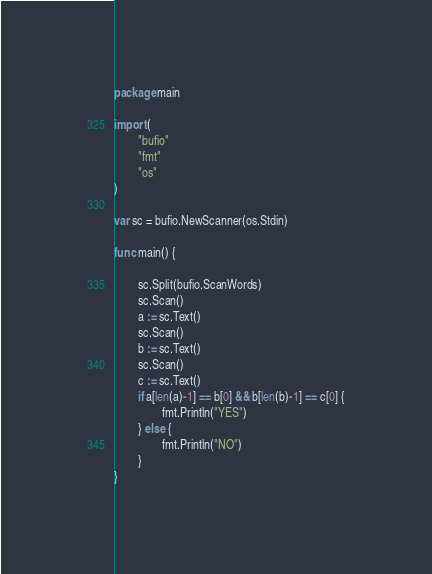Convert code to text. <code><loc_0><loc_0><loc_500><loc_500><_Go_>package main

import (
        "bufio"
        "fmt"
        "os"
)

var sc = bufio.NewScanner(os.Stdin)

func main() {

        sc.Split(bufio.ScanWords)
        sc.Scan()
        a := sc.Text()
        sc.Scan()
        b := sc.Text()
        sc.Scan()
        c := sc.Text()
        if a[len(a)-1] == b[0] && b[len(b)-1] == c[0] {
                fmt.Println("YES")
        } else {
                fmt.Println("NO")
        }
}</code> 